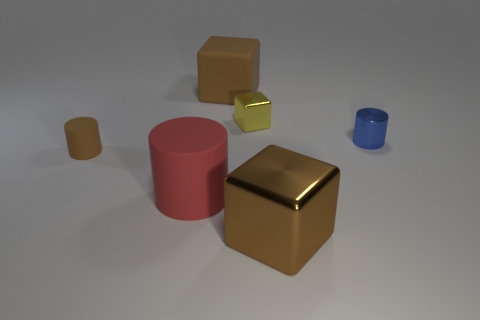Can you describe the texture of the objects? Certainly! The objects in the image appear to have different textures. The large brown cube and the pink cylinder seem to have a matte finish, while the smaller gold cube looks to be quite reflective, suggesting a metallic texture. The blue cylinder appears to have a smooth finish, and the yellow square items may have a rubbery texture as they lack the reflective quality seen in the gold cube. 